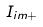<formula> <loc_0><loc_0><loc_500><loc_500>I _ { i m + }</formula> 